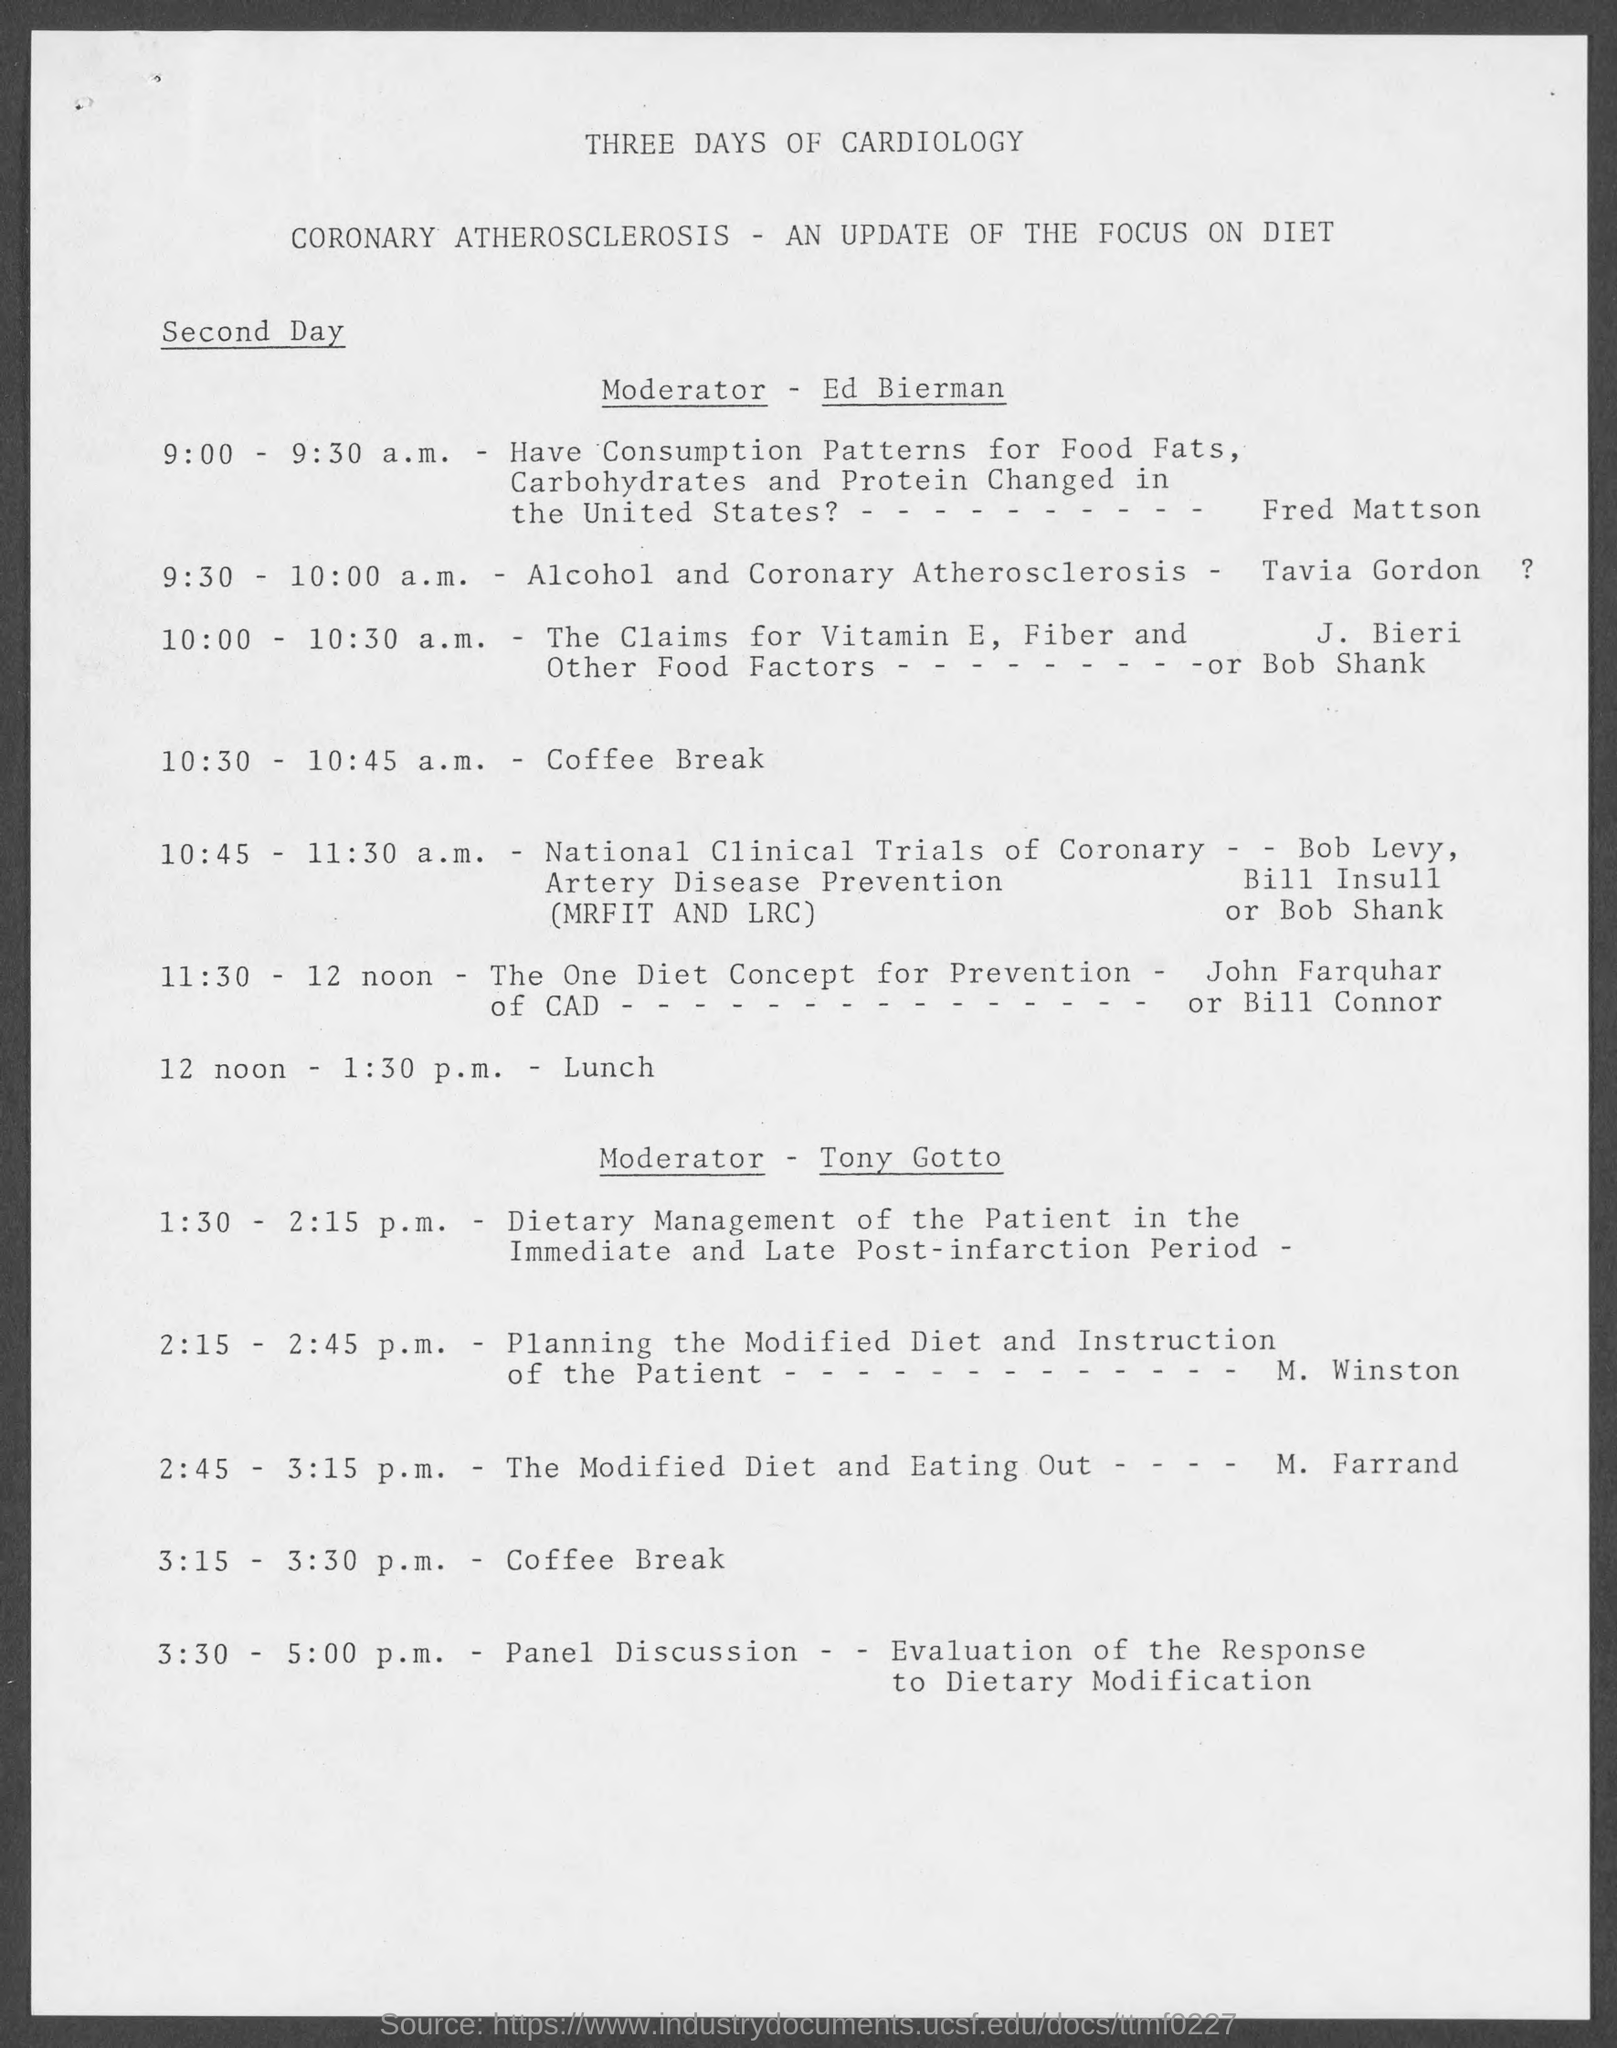When is the Lunch?
Your answer should be very brief. 12 noon - 1:30 p.m. 